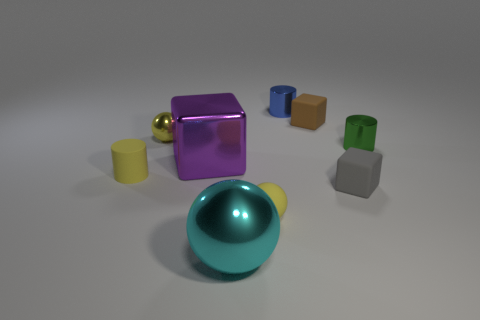Subtract all cubes. How many objects are left? 6 Subtract 1 green cylinders. How many objects are left? 8 Subtract all big yellow cylinders. Subtract all matte objects. How many objects are left? 5 Add 9 matte cylinders. How many matte cylinders are left? 10 Add 8 big gray matte cylinders. How many big gray matte cylinders exist? 8 